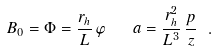Convert formula to latex. <formula><loc_0><loc_0><loc_500><loc_500>B _ { 0 } = \Phi = \frac { r _ { h } } { L } \, \varphi \quad a = \frac { r _ { h } ^ { 2 } } { L ^ { 3 } } \, \frac { p } { z } \ .</formula> 